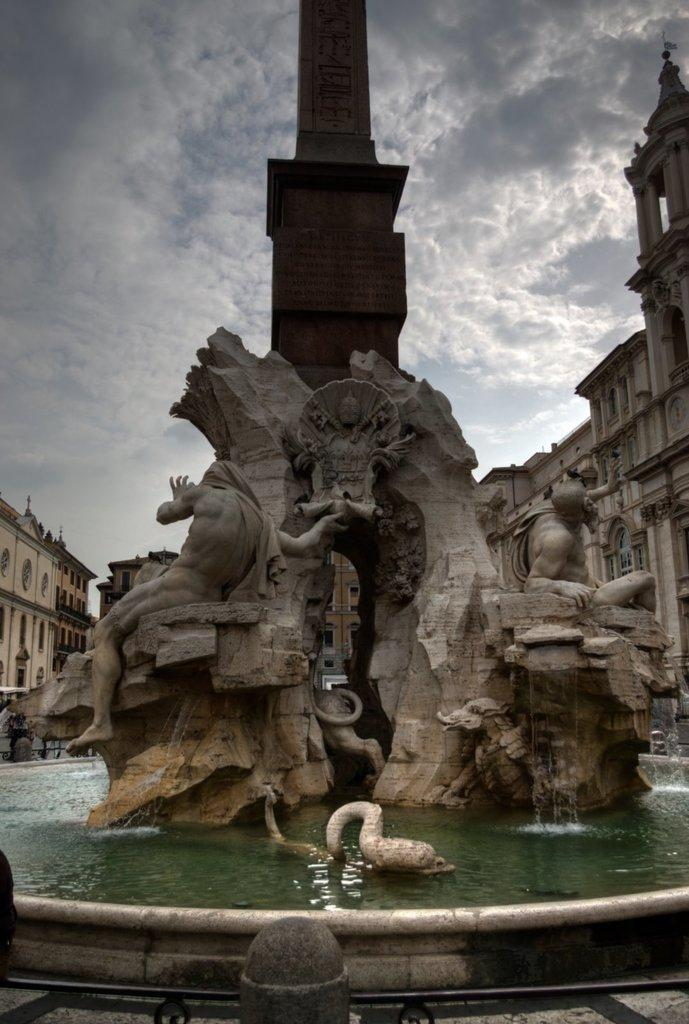What is the primary element present in the image? There is water in the image. What type of objects can be seen in the water? There are statues of persons in the image. What other object is present in the image? There is a pole in the image. What can be seen in the background of the image? There are buildings and the sky visible in the background of the image. How much salt is dissolved in the water in the image? There is no information about the salt content in the water in the image, so it cannot be determined. 